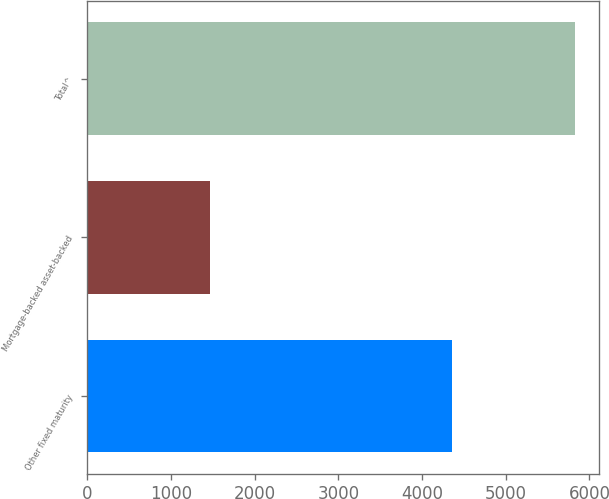Convert chart. <chart><loc_0><loc_0><loc_500><loc_500><bar_chart><fcel>Other fixed maturity<fcel>Mortgage-backed asset-backed<fcel>Total^<nl><fcel>4354<fcel>1470<fcel>5824<nl></chart> 